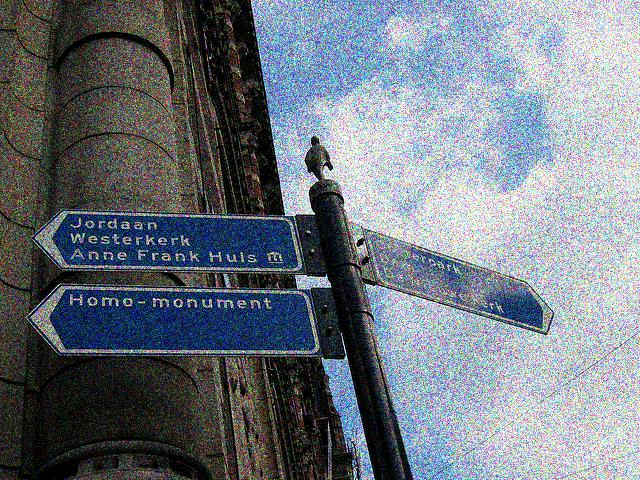Can you describe the significance of the signs in the image? The signs appear to be directional street signs in an urban setting, pointing to notable locations. These landmarks, indicated by the signs, are likely of historical and cultural importance, directing pedestrians to key attractions or districts within the city. 